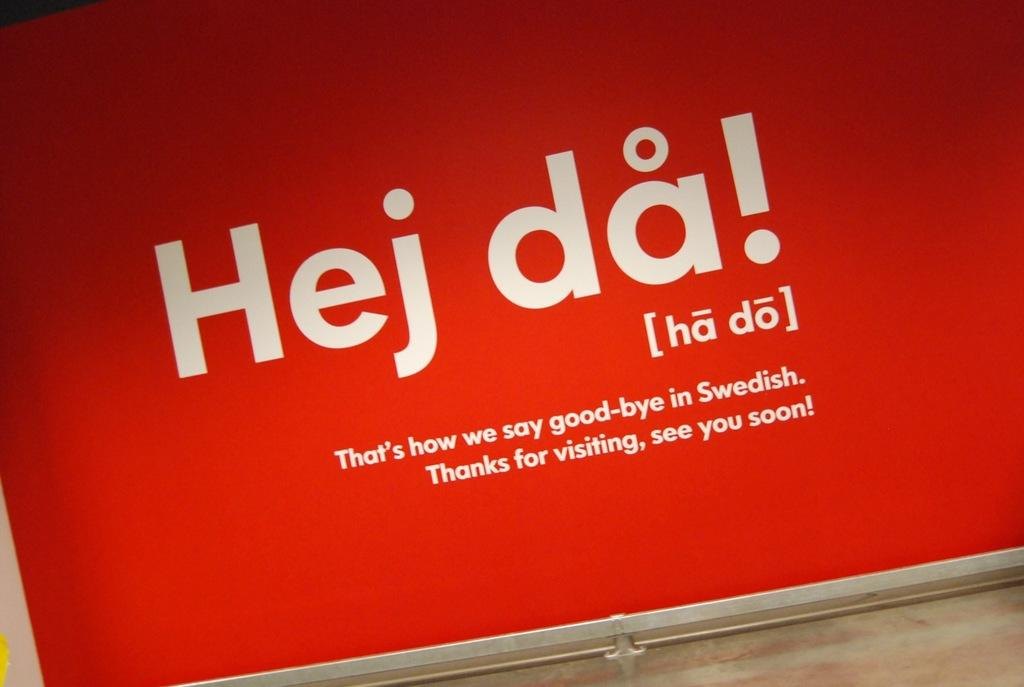Provide a one-sentence caption for the provided image. A sign shows how to say good bye in the Swedish language. 